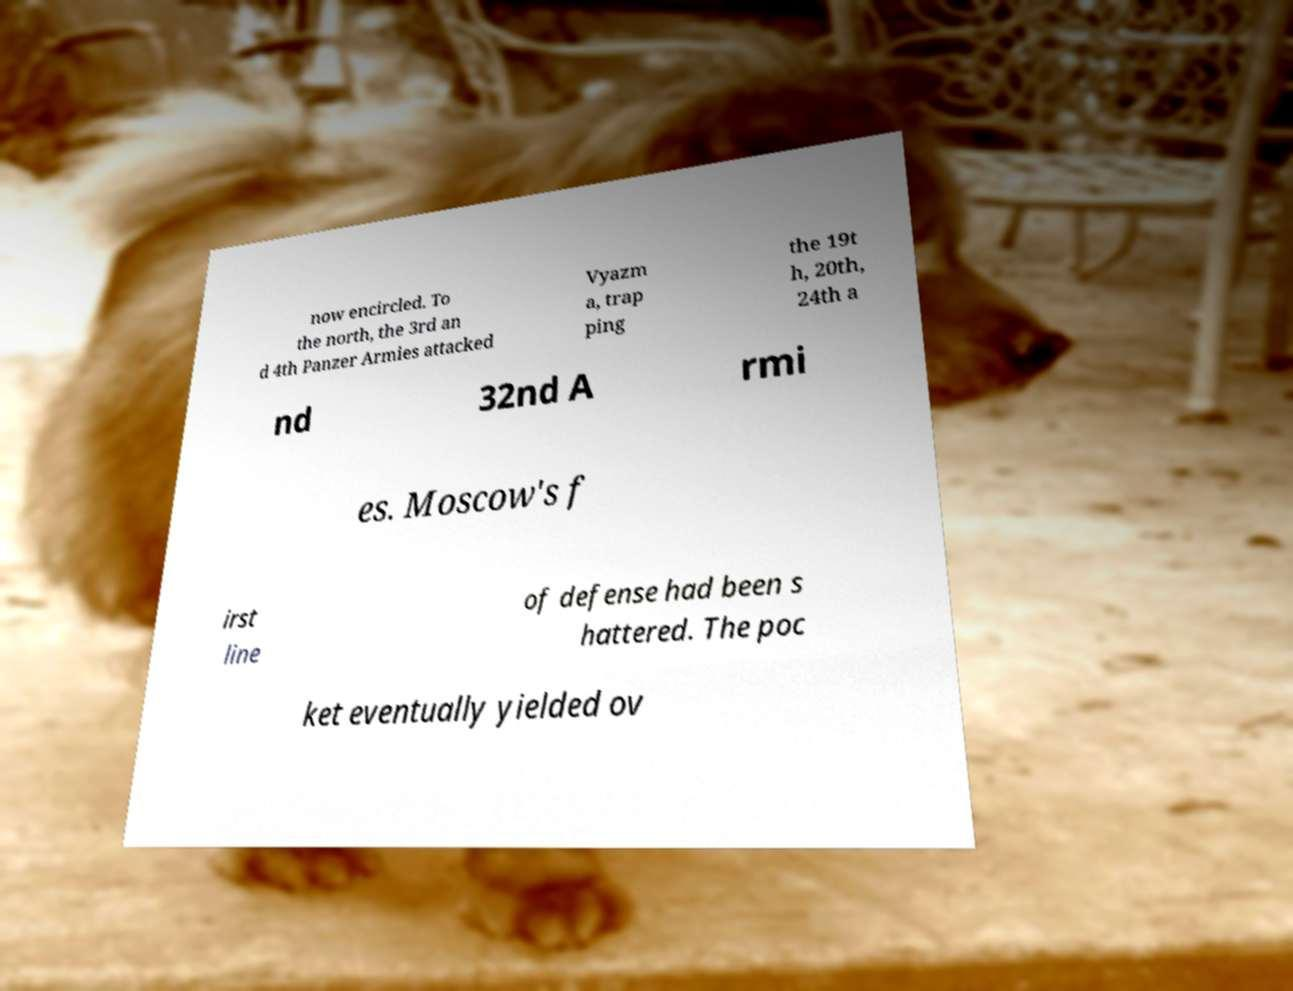Can you read and provide the text displayed in the image?This photo seems to have some interesting text. Can you extract and type it out for me? now encircled. To the north, the 3rd an d 4th Panzer Armies attacked Vyazm a, trap ping the 19t h, 20th, 24th a nd 32nd A rmi es. Moscow's f irst line of defense had been s hattered. The poc ket eventually yielded ov 